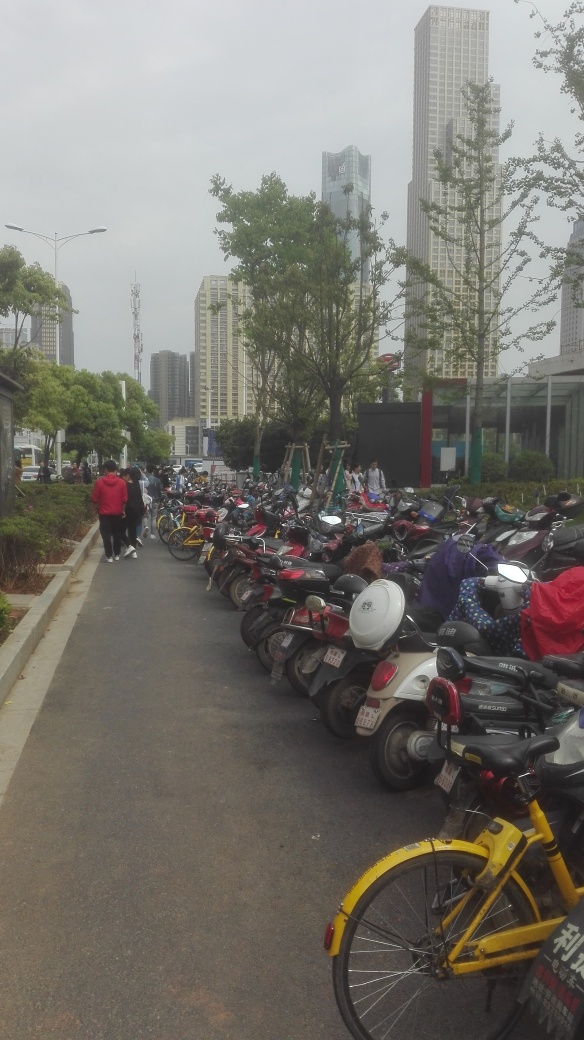Is the image of excellent quality? The image clarity is decent, allowing viewers to make out details such as the rows of parked motorcycles and the distant buildings. However, it appears slightly overexposed and lacks sharpness, which detracts from the overall quality. An image of excellent quality would typically have balanced lighting, high definition, and vibrant colors. 